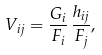Convert formula to latex. <formula><loc_0><loc_0><loc_500><loc_500>V _ { i j } = \frac { G _ { i } } { F _ { i } } \, \frac { h _ { i j } } { F _ { j } } ,</formula> 